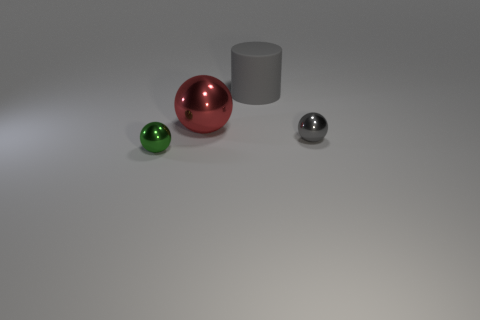Add 4 large gray rubber cylinders. How many objects exist? 8 Subtract all cylinders. How many objects are left? 3 Add 4 red shiny spheres. How many red shiny spheres are left? 5 Add 3 tiny green shiny spheres. How many tiny green shiny spheres exist? 4 Subtract 0 purple balls. How many objects are left? 4 Subtract all big yellow metallic objects. Subtract all rubber objects. How many objects are left? 3 